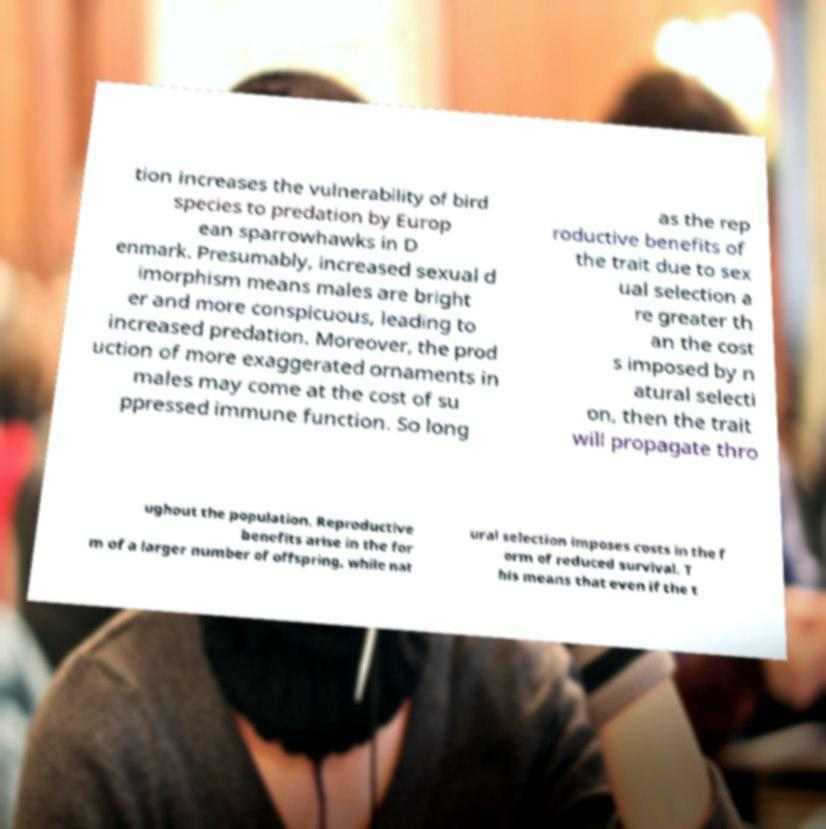Could you assist in decoding the text presented in this image and type it out clearly? tion increases the vulnerability of bird species to predation by Europ ean sparrowhawks in D enmark. Presumably, increased sexual d imorphism means males are bright er and more conspicuous, leading to increased predation. Moreover, the prod uction of more exaggerated ornaments in males may come at the cost of su ppressed immune function. So long as the rep roductive benefits of the trait due to sex ual selection a re greater th an the cost s imposed by n atural selecti on, then the trait will propagate thro ughout the population. Reproductive benefits arise in the for m of a larger number of offspring, while nat ural selection imposes costs in the f orm of reduced survival. T his means that even if the t 